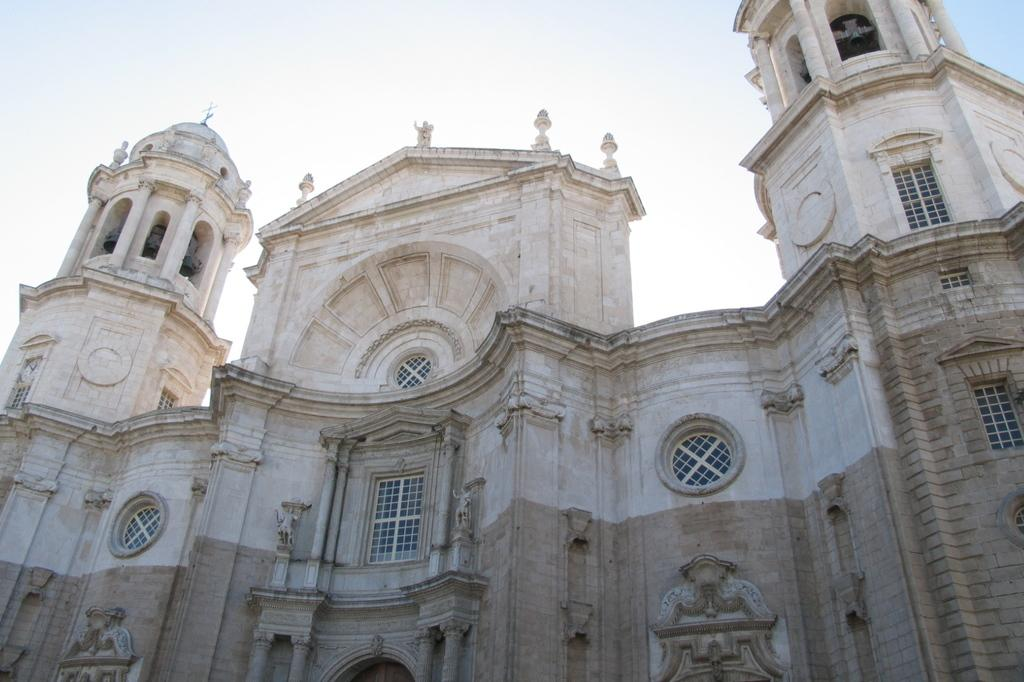What type of structure is present in the image? There is a building in the image. Can you describe the color of the building? The building is brown and cream in color. What feature can be seen on the building? The building has windows. What is placed on top of the building? There are beers on top of the building. What can be seen in the background of the image? The sky is visible in the background of the image. Can you tell me how many potatoes are visible on the roof of the building in the image? There are no potatoes visible on the roof of the building in the image. Is there a gun being fired in the image? There is no gun or any indication of gunfire in the image. 